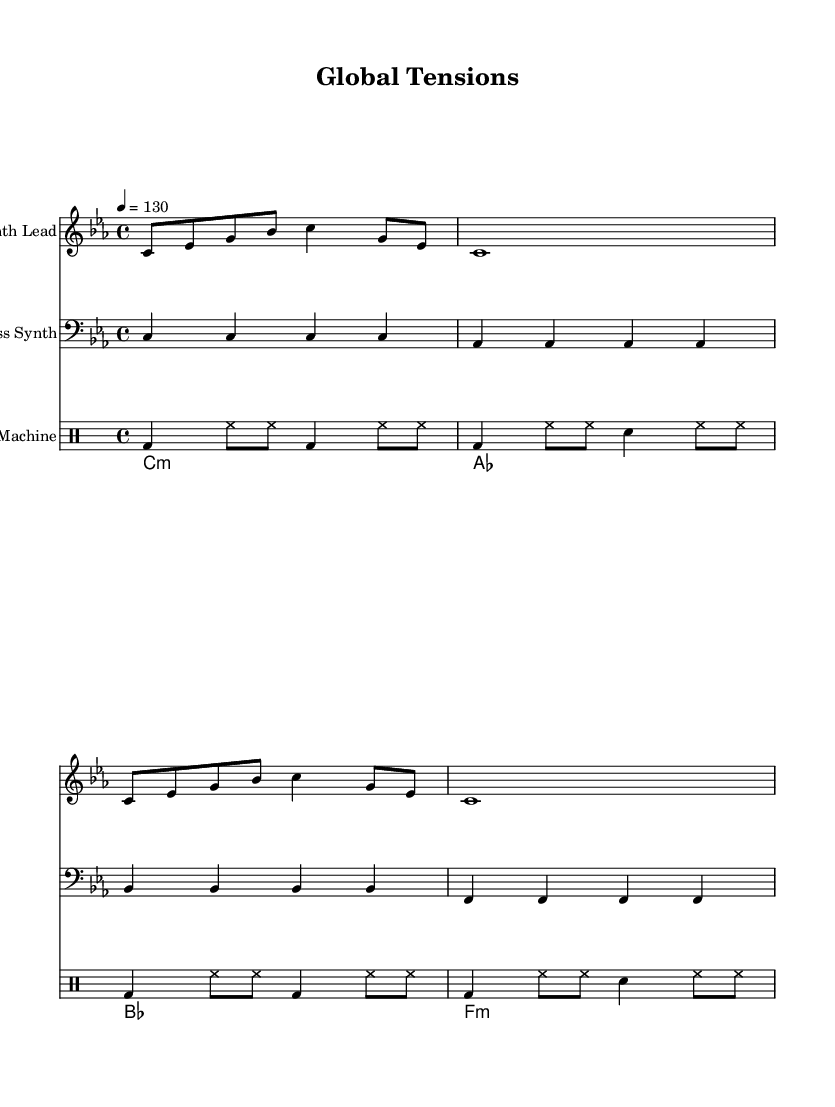What is the key signature of this music? The key signature is C minor, which consists of three flats (B♭, E♭, A♭). This is indicated at the beginning of the sheet music.
Answer: C minor What is the time signature for this piece? The time signature is 4/4, which is noted at the beginning of the music. This means there are four beats in a measure, and the quarter note receives one beat.
Answer: 4/4 What is the tempo marking provided? The tempo marking is 130 beats per minute, specified as "4 = 130." This indicates the speed at which the music should be performed.
Answer: 130 How many measures are in the synth lead section? There are four measures in the synth lead section, which can be counted visually through the music, where each line in the staff contains four beats grouped into measures.
Answer: 4 What instruments are used in this composition? The instruments indicated are a Synth Lead, Bass Synth, Drum Machine, and Pad Synth, each labeled at the beginning of their respective staffs.
Answer: Synth Lead, Bass Synth, Drum Machine, Pad Synth What genre does this composition represent? This composition is characterized by its use of synthesizers and electronic elements, indicative of the Electronic genre. The tension and urgency of the rhythms suggest it's related to techno-infused music.
Answer: Electronic 